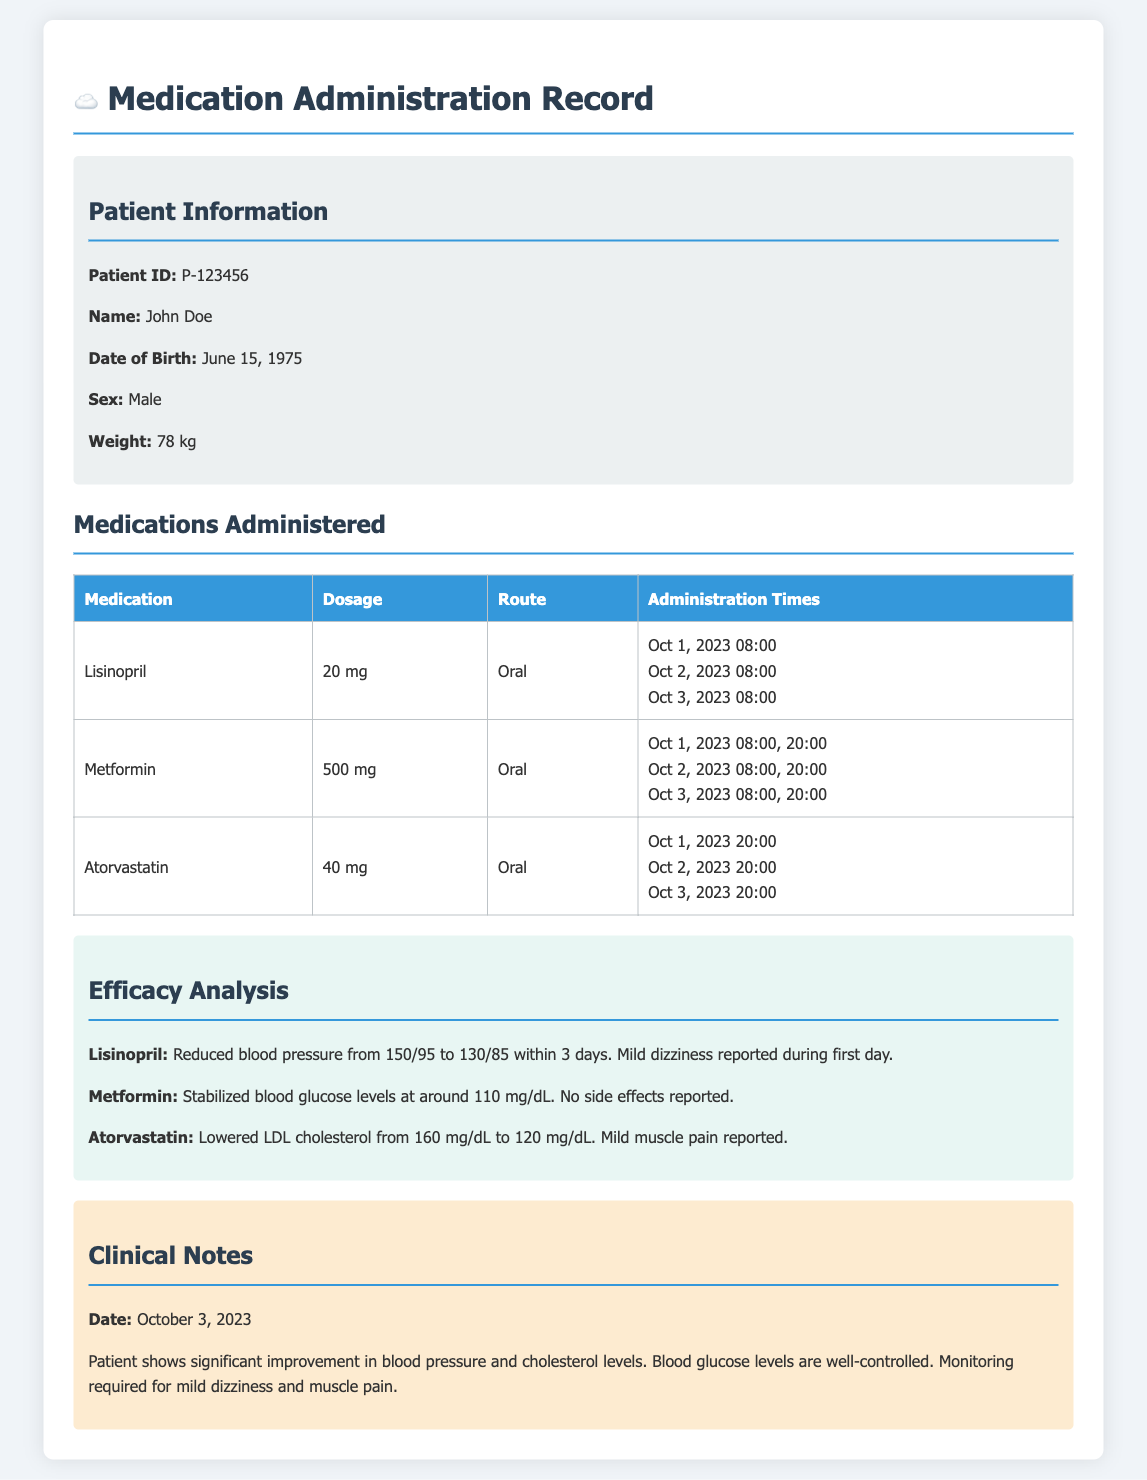what is the Patient ID? The Patient ID is specified in the patient information section of the document.
Answer: P-123456 when was the last medication administration of Metformin? The last administration time of Metformin can be found in the medication administration table.
Answer: Oct 3, 2023 20:00 what dosage of Atorvastatin was administered? The dosage for Atorvastatin is included in the medication table compiled in the document.
Answer: 40 mg how much did Lisinopril lower the blood pressure? The efficacy analysis outlines the changes in blood pressure due to Lisinopril.
Answer: 20/10 what are the side effects reported for Metformin? The efficacy analysis discusses any side effects related to medications administered, specifically noting any for Metformin.
Answer: No side effects reported how many times was Metformin administered on Oct 2, 2023? The medication administration times indicate the frequency of administration on that day.
Answer: 2 times which clinical issue was observed on October 3, 2023? The clinical notes provide insights on the patient's condition and observations made on that specific date.
Answer: Mild dizziness and muscle pain what is the weight of the patient? The patient's weight is listed in the patient information section of the document.
Answer: 78 kg 